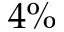<formula> <loc_0><loc_0><loc_500><loc_500>4 \%</formula> 